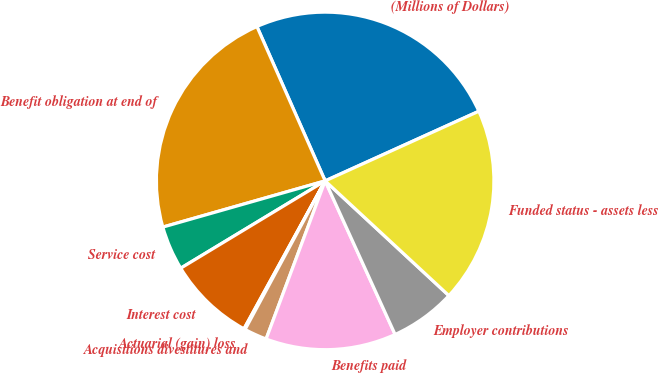<chart> <loc_0><loc_0><loc_500><loc_500><pie_chart><fcel>(Millions of Dollars)<fcel>Benefit obligation at end of<fcel>Service cost<fcel>Interest cost<fcel>Actuarial (gain) loss<fcel>Acquisitions divestitures and<fcel>Benefits paid<fcel>Employer contributions<fcel>Funded status - assets less<nl><fcel>24.85%<fcel>22.79%<fcel>4.24%<fcel>8.36%<fcel>0.12%<fcel>2.18%<fcel>12.49%<fcel>6.3%<fcel>18.67%<nl></chart> 